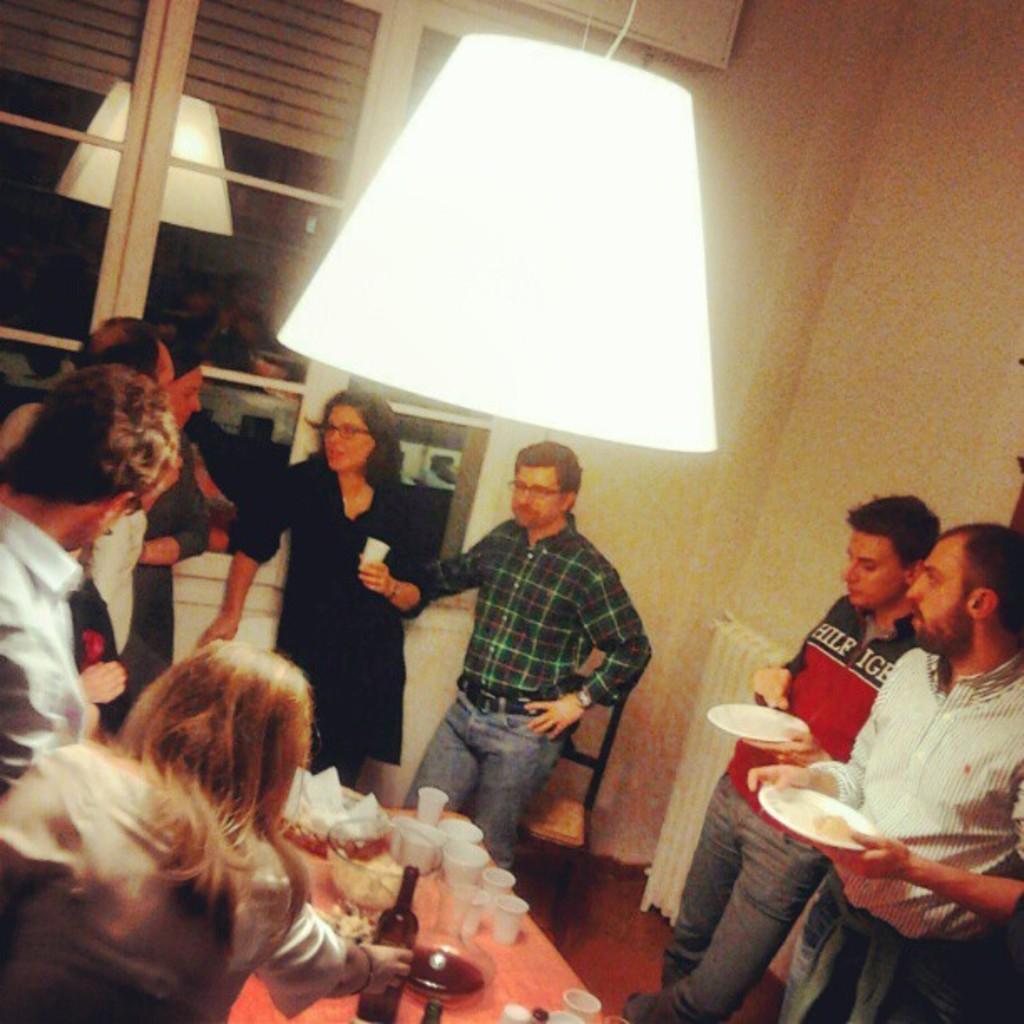Describe this image in one or two sentences. In this image we can see the people standing on the floor. We can see a woman holding the glass. We can also see the chair and also the table. On the table we can see a bottle, glasses and also the bowls of food items. We can also see the window, wall and also a lamp hangs from the ceiling. 